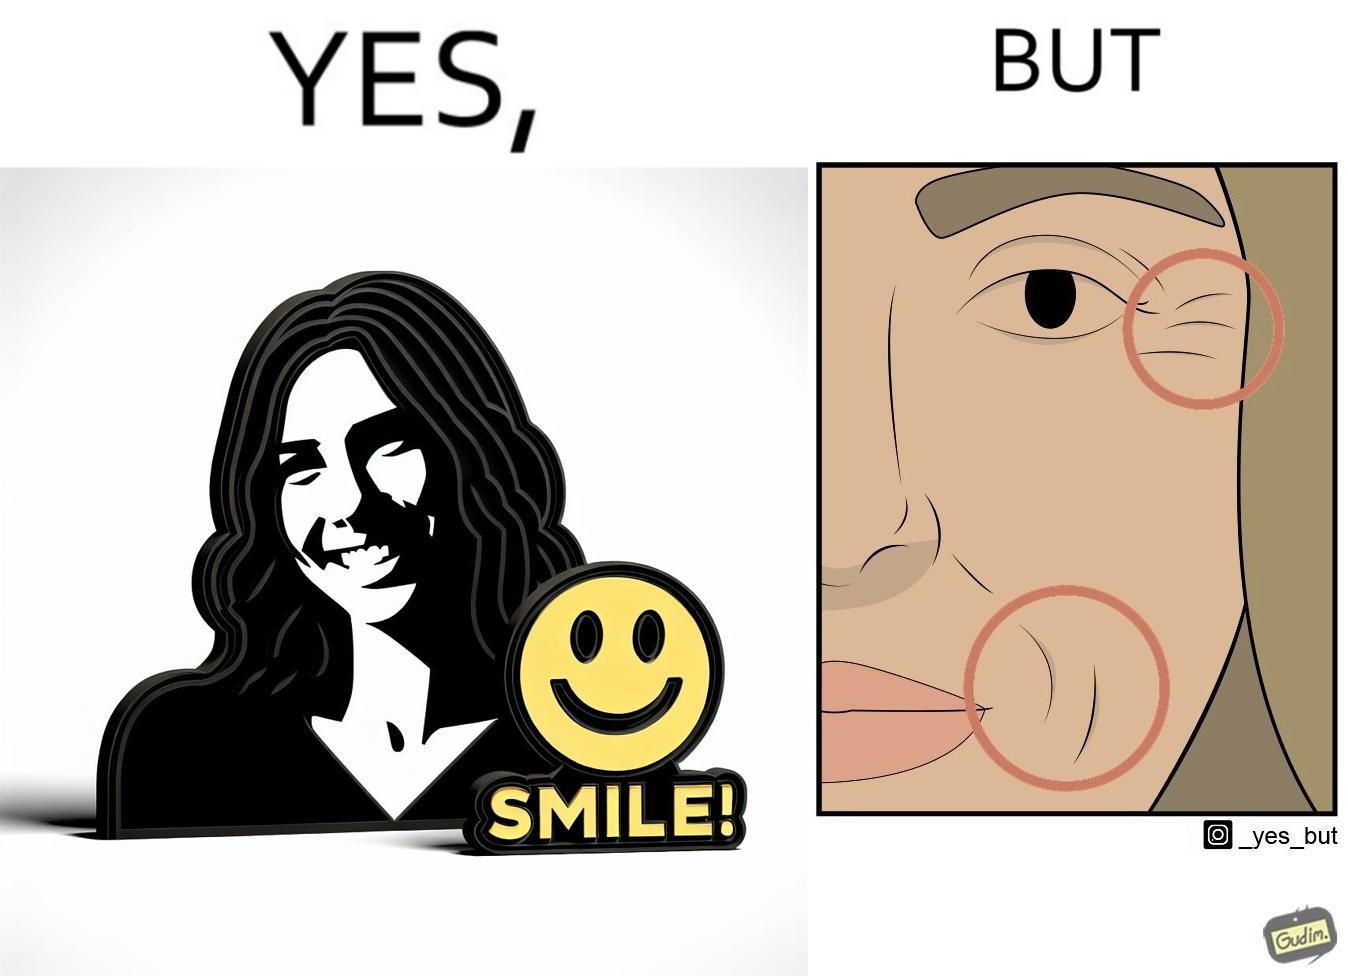Describe the contrast between the left and right parts of this image. In the left part of the image: The image shows a woman smiling with a text saying the word "smile!".  There is also a yellow smiley face in the image. In the right part of the image: The image shows a closeup of the face of a woman. The image has red circles around the wrinkles near the woman's lips and eyes highlighting them. 